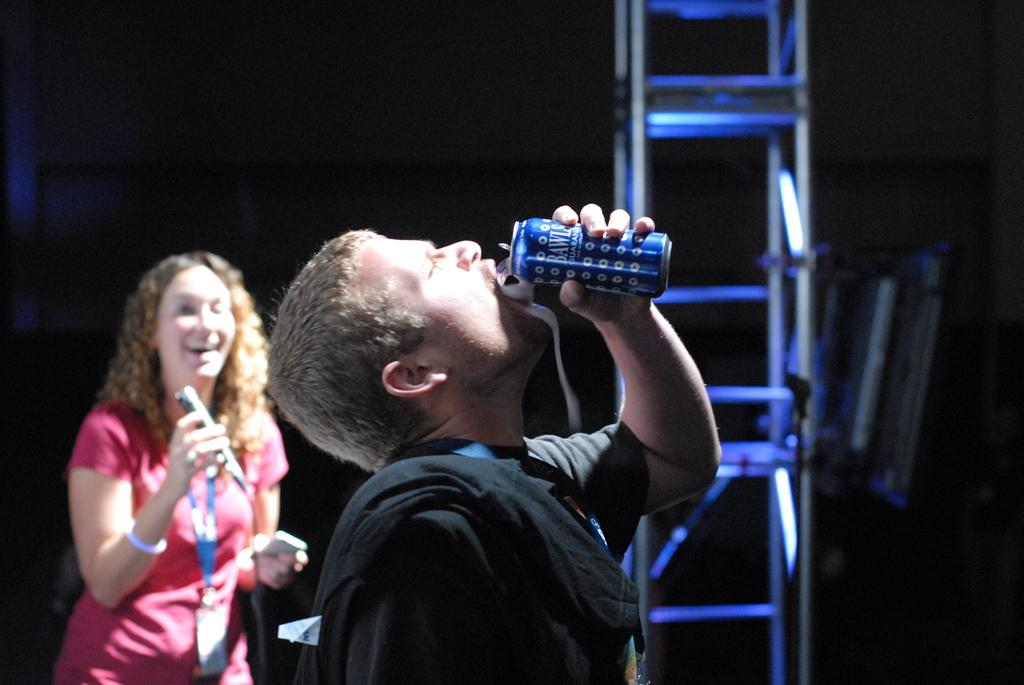How many people are present in the image? There are two people in the image. What is one person doing in the image? One person is drinking something. What object is the other person holding in the image? The other person is holding a microphone (mic). What type of twig is the person holding in the image? There is no twig present in the image; one person is holding a microphone. What is the income of the people in the image? The income of the people in the image cannot be determined from the image itself. 